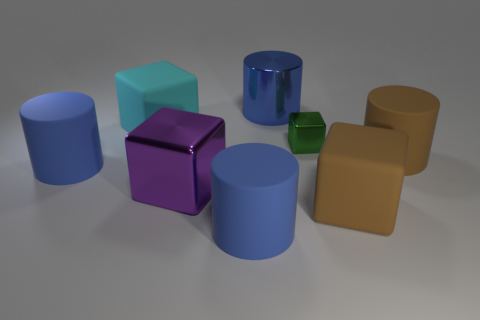Are there any large blue objects on the right side of the tiny green cube? I've carefully examined the image, and indeed, there are no large blue objects located on the right side of the tiny green cube. The right side is occupied by a cylinder of a brownish color, while the large blue objects are situated elsewhere. 